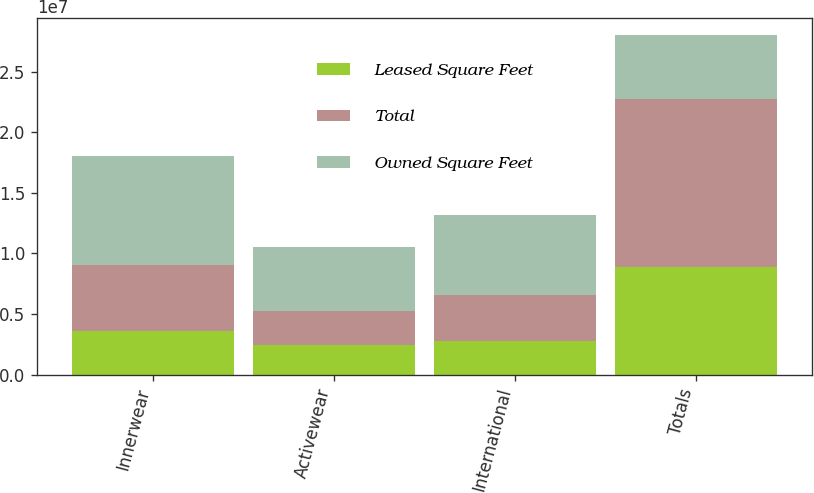Convert chart. <chart><loc_0><loc_0><loc_500><loc_500><stacked_bar_chart><ecel><fcel>Innerwear<fcel>Activewear<fcel>International<fcel>Totals<nl><fcel>Leased Square Feet<fcel>3.62981e+06<fcel>2.45852e+06<fcel>2.80757e+06<fcel>8.8959e+06<nl><fcel>Total<fcel>5.39738e+06<fcel>2.81266e+06<fcel>3.764e+06<fcel>1.38417e+07<nl><fcel>Owned Square Feet<fcel>9.02719e+06<fcel>5.27118e+06<fcel>6.57156e+06<fcel>5.27118e+06<nl></chart> 